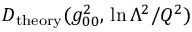<formula> <loc_0><loc_0><loc_500><loc_500>D _ { t h e o r y } ( g _ { 0 0 } ^ { 2 } , \, \ln \Lambda ^ { 2 } / Q ^ { 2 } )</formula> 